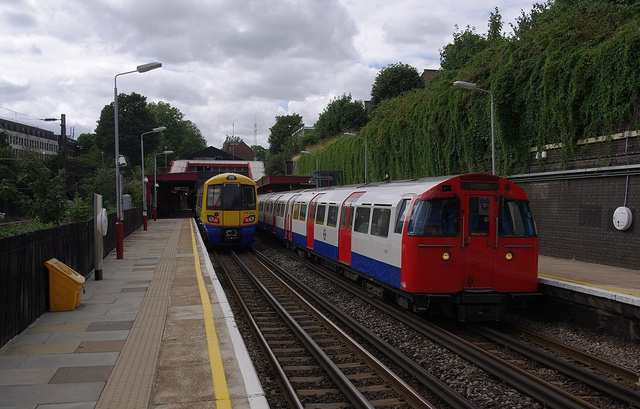Describe the objects in this image and their specific colors. I can see train in lavender, black, maroon, darkgray, and gray tones and train in lavender, black, olive, and maroon tones in this image. 